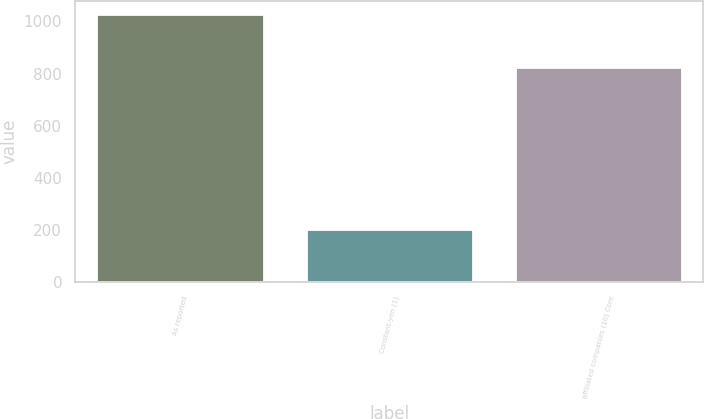Convert chart to OTSL. <chart><loc_0><loc_0><loc_500><loc_500><bar_chart><fcel>As reported<fcel>Constant-yen (1)<fcel>affiliated companies (10) Core<nl><fcel>1027<fcel>202<fcel>825<nl></chart> 